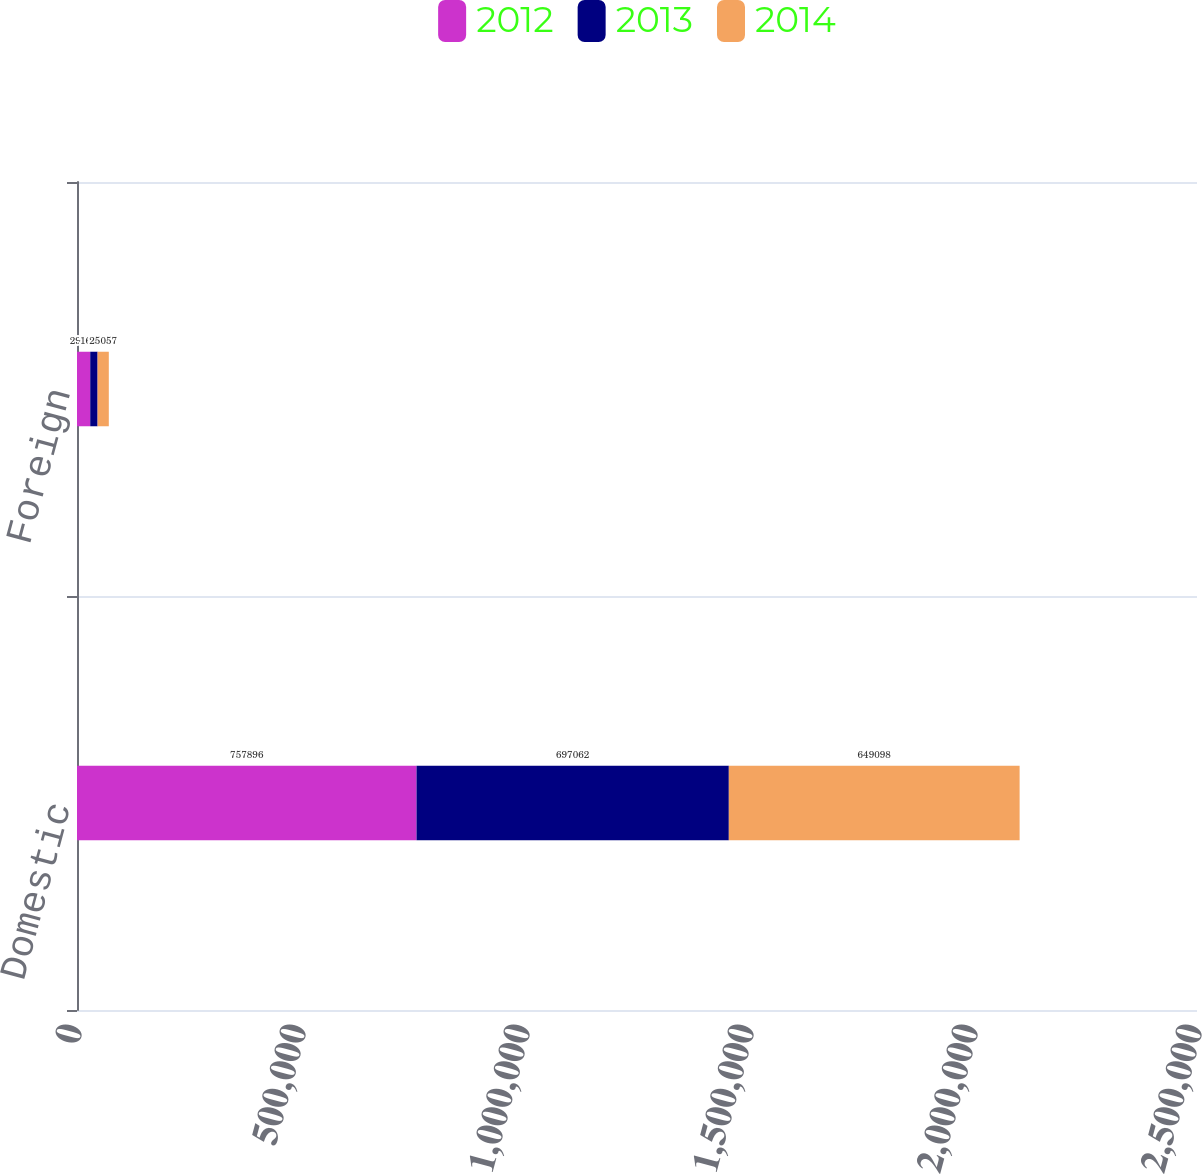<chart> <loc_0><loc_0><loc_500><loc_500><stacked_bar_chart><ecel><fcel>Domestic<fcel>Foreign<nl><fcel>2012<fcel>757896<fcel>29538<nl><fcel>2013<fcel>697062<fcel>16406<nl><fcel>2014<fcel>649098<fcel>25057<nl></chart> 